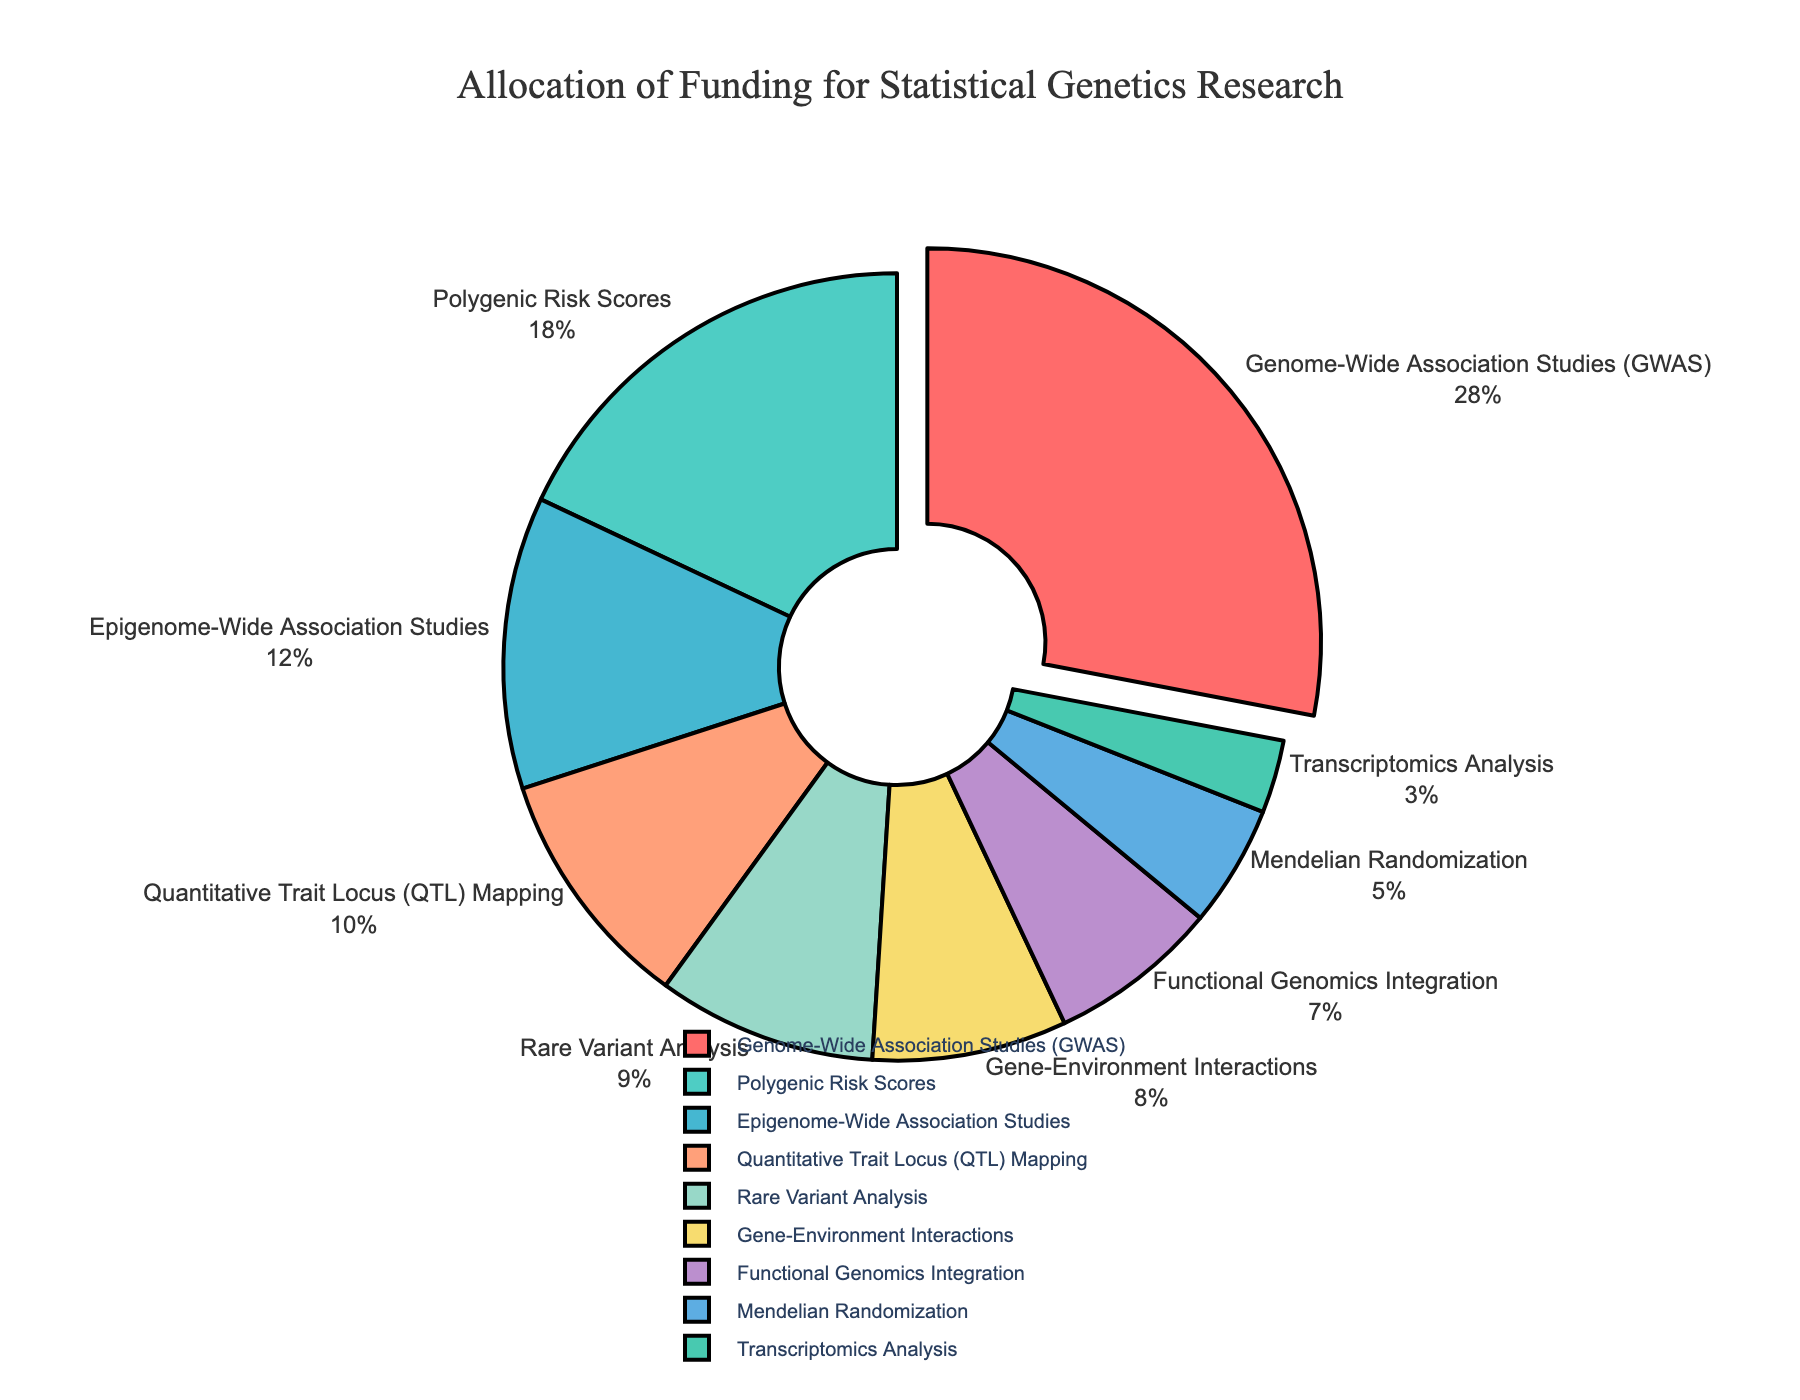What's the research area with the highest funding allocation? The chart shows that Genome-Wide Association Studies (GWAS) has the largest slice, which is also pulled out for emphasis, indicating it receives the highest funding allocation at 28%.
Answer: Genome-Wide Association Studies (GWAS) What's the total funding allocation for Epigenome-Wide Association Studies and Transcriptomics Analysis? The funding for Epigenome-Wide Association Studies is 12%, and for Transcriptomics Analysis, it is 3%. Adding them together gives 12 + 3 = 15%.
Answer: 15% Which two research areas have equal funding allocations and what is their combined percentage? The data indicates that there are no two research areas with equal funding allocations. The percentages are all unique.
Answer: None Which research area receives less funding, Quantitative Trait Locus (QTL) Mapping or Rare Variant Analysis? Quantitative Trait Locus (QTL) Mapping has a funding allocation of 10%, whereas Rare Variant Analysis has 9%. Since 9% is less than 10%, Rare Variant Analysis receives less funding.
Answer: Rare Variant Analysis What research areas are represented by the colors red and green in the chart? In the chart, the color red represents Genome-Wide Association Studies (GWAS) with 28%, and the color green represents Polygenic Risk Scores with 18%.
Answer: Genome-Wide Association Studies (GWAS) and Polygenic Risk Scores What is the combined funding allocation for the research areas related to genome and genomics (i.e., GWAS, Functional Genomics Integration, and Transcriptomics Analysis)? The funding allocation for Genome-Wide Association Studies (GWAS) is 28%, for Functional Genomics Integration is 7%, and for Transcriptomics Analysis is 3%. Adding them together gives 28 + 7 + 3 = 38%.
Answer: 38% Is the funding allocation for Mendelian Randomization greater than the funding for Gene-Environment Interactions? Mendelian Randomization receives 5% of the funding, while Gene-Environment Interactions receives 8%. Since 5% is less than 8%, the funding for Mendelian Randomization is not greater.
Answer: No What slice is the smallest in the pie chart, and what percentage does it represent? The smallest slice in the pie chart is for Transcriptomics Analysis, which represents 3% of the total funding allocation.
Answer: Transcriptomics Analysis, 3% What is the difference in funding allocation between Polygenic Risk Scores and Mendelian Randomization? The funding allocation for Polygenic Risk Scores is 18%, and for Mendelian Randomization, it is 5%. The difference between the two is 18 - 5 = 13%.
Answer: 13% What percent of the funding is allocated to research areas with less than 10% funding individually? The research areas with less than 10% individual funding are Rare Variant Analysis (9%), Gene-Environment Interactions (8%), Functional Genomics Integration (7%), Mendelian Randomization (5%), and Transcriptomics Analysis (3%). The combined funding for these areas is 9 + 8 + 7 + 5 + 3 = 32%.
Answer: 32% 